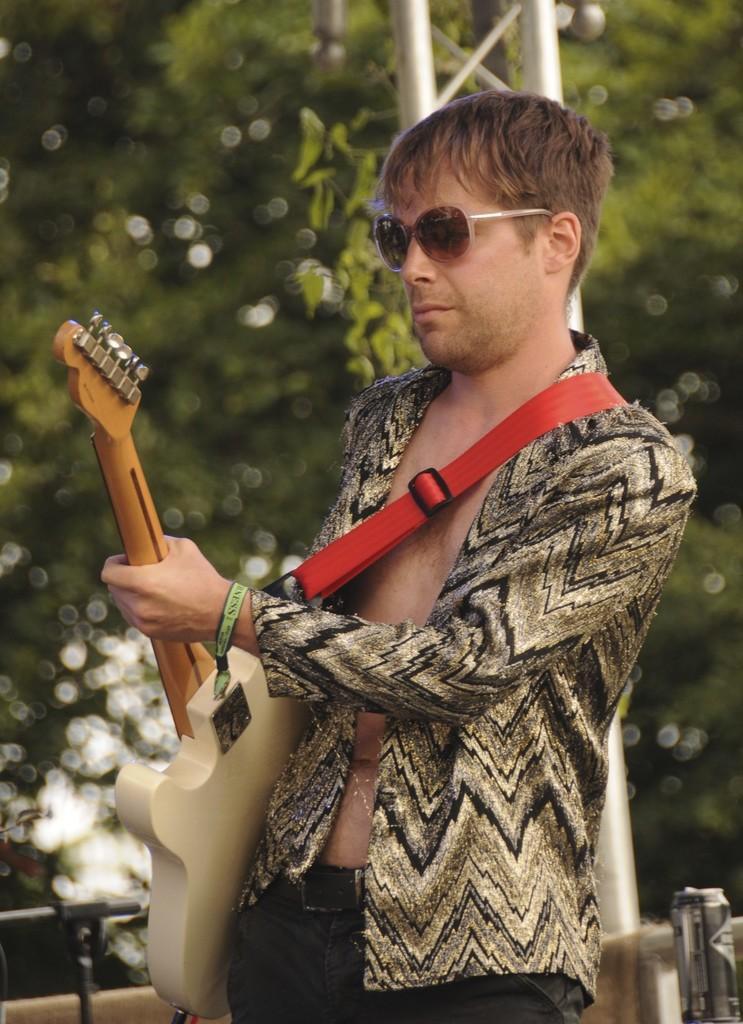Can you describe this image briefly? In this image i can see a person wearing a blazer and a black pant is standing and holding a guitar in his hands. In the background i can see a metal pole and few trees. 